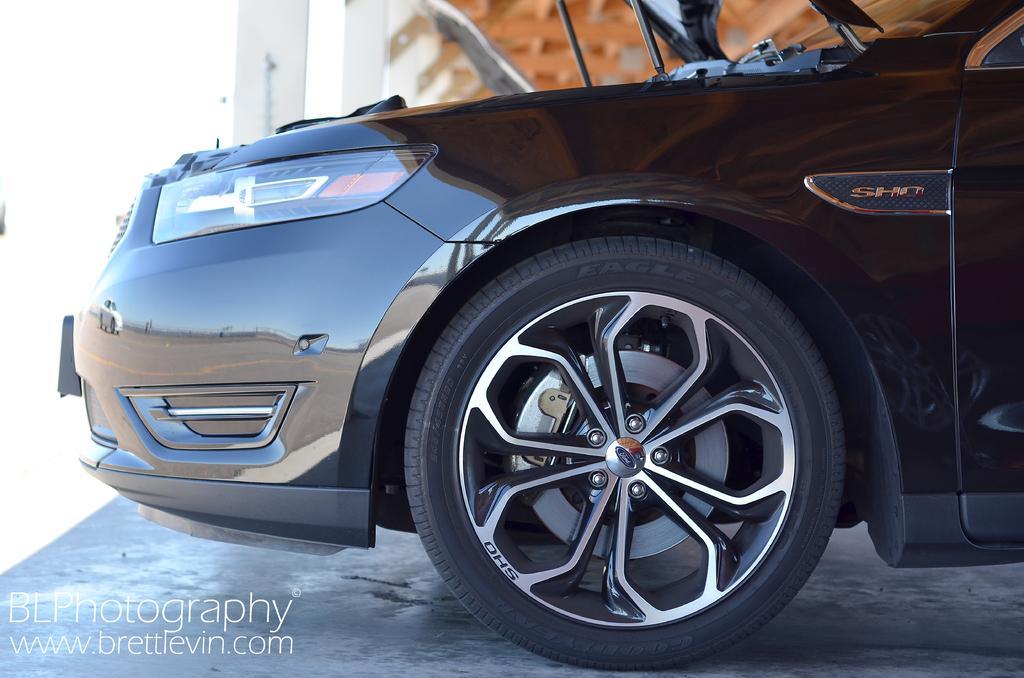How would you summarize this image in a sentence or two? In this picture there is a car and there is something written in the left bottom corner. 